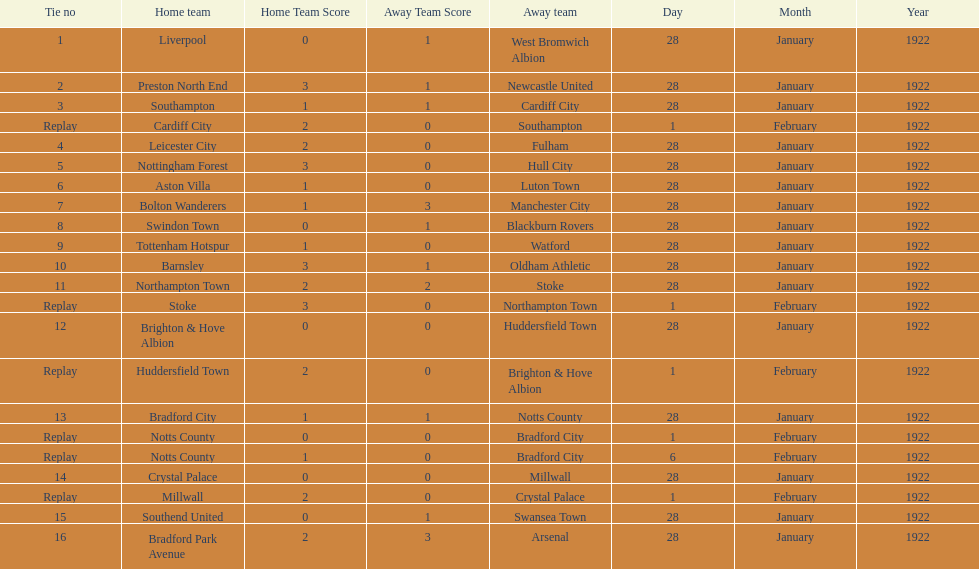Parse the full table. {'header': ['Tie no', 'Home team', 'Home Team Score', 'Away Team Score', 'Away team', 'Day', 'Month', 'Year'], 'rows': [['1', 'Liverpool', '0', '1', 'West Bromwich Albion', '28', 'January', '1922'], ['2', 'Preston North End', '3', '1', 'Newcastle United', '28', 'January', '1922'], ['3', 'Southampton', '1', '1', 'Cardiff City', '28', 'January', '1922'], ['Replay', 'Cardiff City', '2', '0', 'Southampton', '1', 'February', '1922'], ['4', 'Leicester City', '2', '0', 'Fulham', '28', 'January', '1922'], ['5', 'Nottingham Forest', '3', '0', 'Hull City', '28', 'January', '1922'], ['6', 'Aston Villa', '1', '0', 'Luton Town', '28', 'January', '1922'], ['7', 'Bolton Wanderers', '1', '3', 'Manchester City', '28', 'January', '1922'], ['8', 'Swindon Town', '0', '1', 'Blackburn Rovers', '28', 'January', '1922'], ['9', 'Tottenham Hotspur', '1', '0', 'Watford', '28', 'January', '1922'], ['10', 'Barnsley', '3', '1', 'Oldham Athletic', '28', 'January', '1922'], ['11', 'Northampton Town', '2', '2', 'Stoke', '28', 'January', '1922'], ['Replay', 'Stoke', '3', '0', 'Northampton Town', '1', 'February', '1922'], ['12', 'Brighton & Hove Albion', '0', '0', 'Huddersfield Town', '28', 'January', '1922'], ['Replay', 'Huddersfield Town', '2', '0', 'Brighton & Hove Albion', '1', 'February', '1922'], ['13', 'Bradford City', '1', '1', 'Notts County', '28', 'January', '1922'], ['Replay', 'Notts County', '0', '0', 'Bradford City', '1', 'February', '1922'], ['Replay', 'Notts County', '1', '0', 'Bradford City', '6', 'February', '1922'], ['14', 'Crystal Palace', '0', '0', 'Millwall', '28', 'January', '1922'], ['Replay', 'Millwall', '2', '0', 'Crystal Palace', '1', 'February', '1922'], ['15', 'Southend United', '0', '1', 'Swansea Town', '28', 'January', '1922'], ['16', 'Bradford Park Avenue', '2', '3', 'Arsenal', '28', 'January', '1922']]} Which game had a higher total number of goals scored, 1 or 16? 16. 